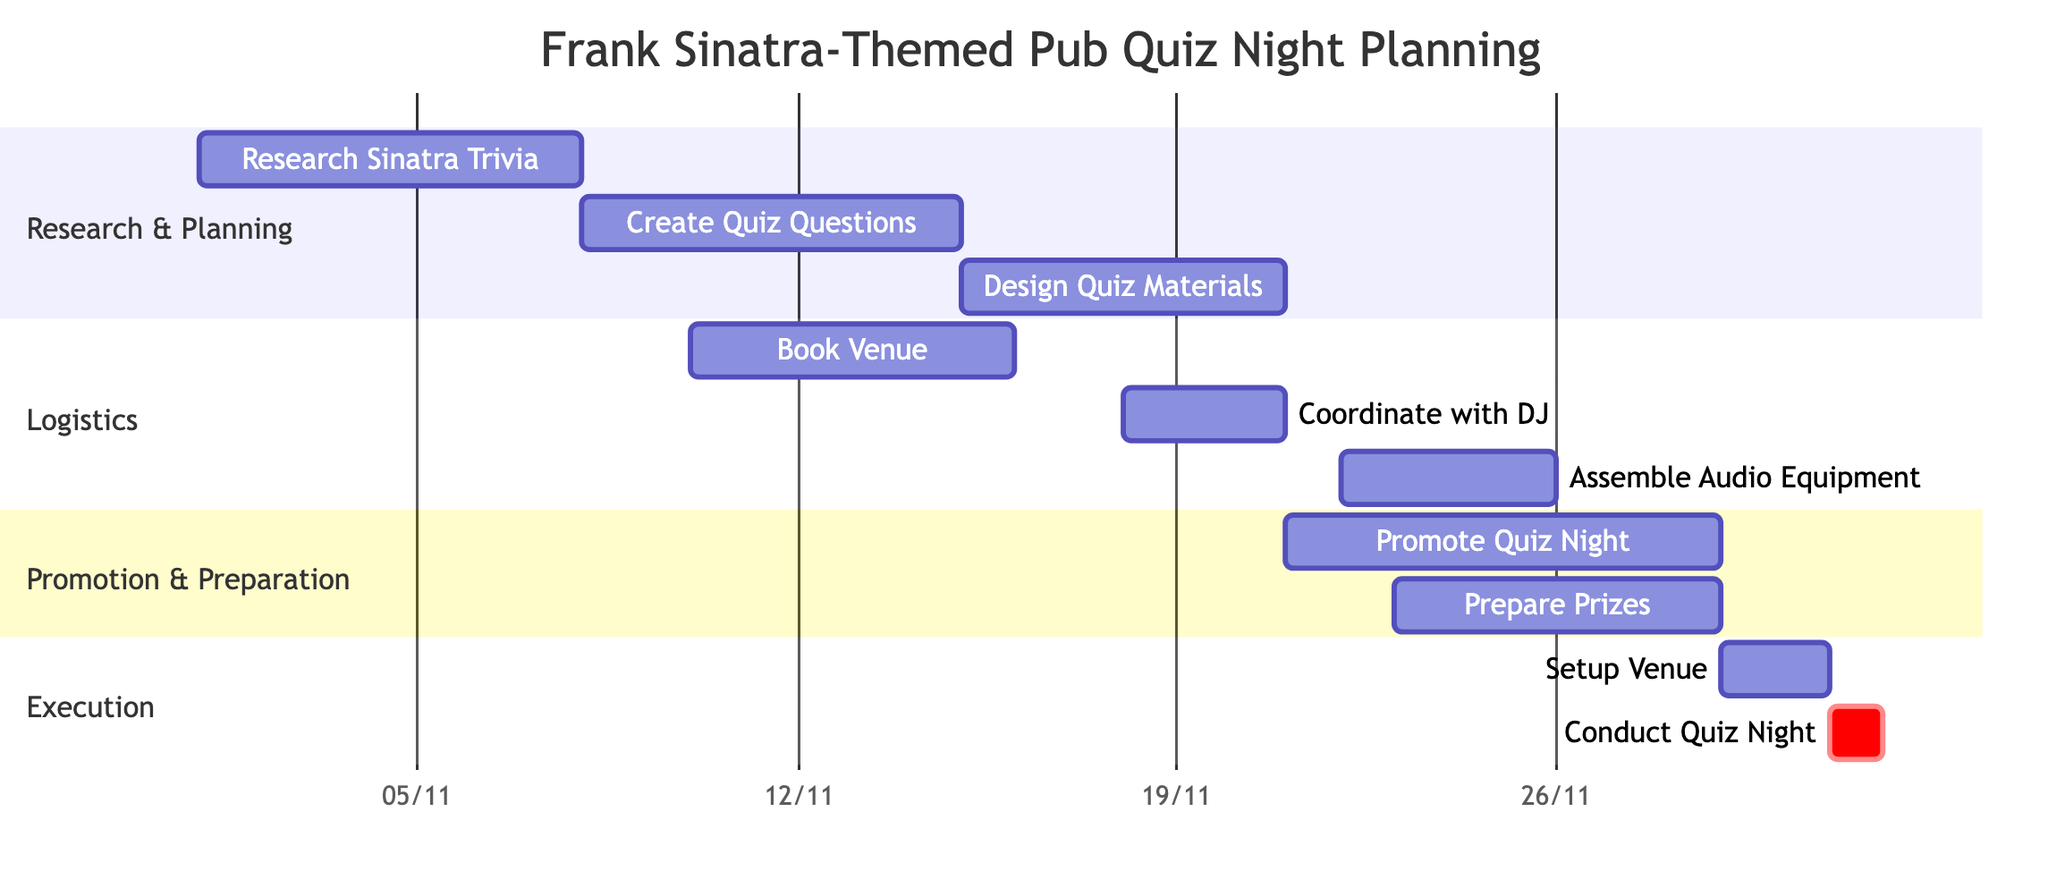What is the first task in the timeline? The first task in the timeline is identified by the earliest start date, which is "Research Sinatra Trivia" starting on "2023-11-01".
Answer: Research Sinatra Trivia How long does "Create Quiz Questions" take? The duration of "Create Quiz Questions" is calculated from its start date of "2023-11-08" to the end date of "2023-11-14", which is 7 days.
Answer: 7 days What task overlaps with "Promote Quiz Night"? The task that overlaps with "Promote Quiz Night", starting on "2023-11-21" and ending on "2023-11-28", includes "Prepare Prizes", which starts on "2023-11-23" and also ends on "2023-11-28".
Answer: Prepare Prizes What is the last task before "Conduct Quiz Night"? The last task before "Conduct Quiz Night" is "Setup Venue", which takes place from "2023-11-29" to "2023-11-30".
Answer: Setup Venue How many tasks are there in total? The total number of tasks is counted from the list provided in the diagram, which shows 10 distinct tasks.
Answer: 10 Which task has the latest end date? The task with the latest end date is "Conduct Quiz Night", which occurs on "2023-12-01".
Answer: Conduct Quiz Night How many days are allocated for "Assemble Audio Equipment"? The duration for "Assemble Audio Equipment" is calculated from the start date of "2023-11-22" to the end date of "2023-11-25", resulting in 4 days total.
Answer: 4 days Which two tasks are scheduled on the same day? Both "Setup Venue" and "Conduct Quiz Night" are scheduled on the same day of "2023-12-01", making them simultaneous tasks.
Answer: Setup Venue and Conduct Quiz Night What is the maximum duration of any single task? The task with the longest duration is "Research Sinatra Trivia," which lasts for 7 days, from "2023-11-01" to "2023-11-07".
Answer: 7 days 